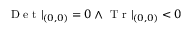<formula> <loc_0><loc_0><loc_500><loc_500>D e t | _ { ( 0 , 0 ) } = 0 \land T r | _ { ( 0 , 0 ) } < 0</formula> 